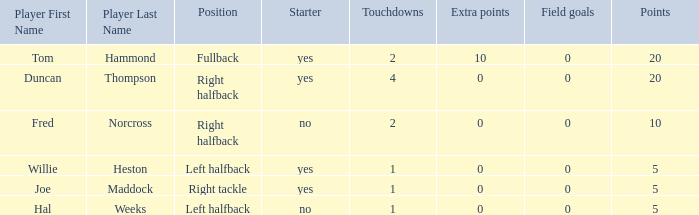How many touchdowns are there when there were 0 extra points and Hal Weeks had left halfback? 1.0. I'm looking to parse the entire table for insights. Could you assist me with that? {'header': ['Player First Name', 'Player Last Name', 'Position', 'Starter', 'Touchdowns', 'Extra points', 'Field goals', 'Points'], 'rows': [['Tom', 'Hammond', 'Fullback', 'yes', '2', '10', '0', '20'], ['Duncan', 'Thompson', 'Right halfback', 'yes', '4', '0', '0', '20'], ['Fred', 'Norcross', 'Right halfback', 'no', '2', '0', '0', '10'], ['Willie', 'Heston', 'Left halfback', 'yes', '1', '0', '0', '5'], ['Joe', 'Maddock', 'Right tackle', 'yes', '1', '0', '0', '5'], ['Hal', 'Weeks', 'Left halfback', 'no', '1', '0', '0', '5']]} 